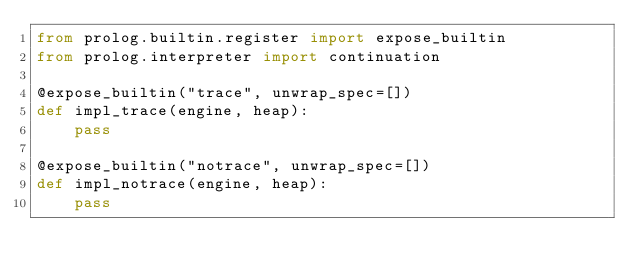Convert code to text. <code><loc_0><loc_0><loc_500><loc_500><_Python_>from prolog.builtin.register import expose_builtin
from prolog.interpreter import continuation

@expose_builtin("trace", unwrap_spec=[])
def impl_trace(engine, heap):
    pass

@expose_builtin("notrace", unwrap_spec=[])
def impl_notrace(engine, heap):
    pass
</code> 